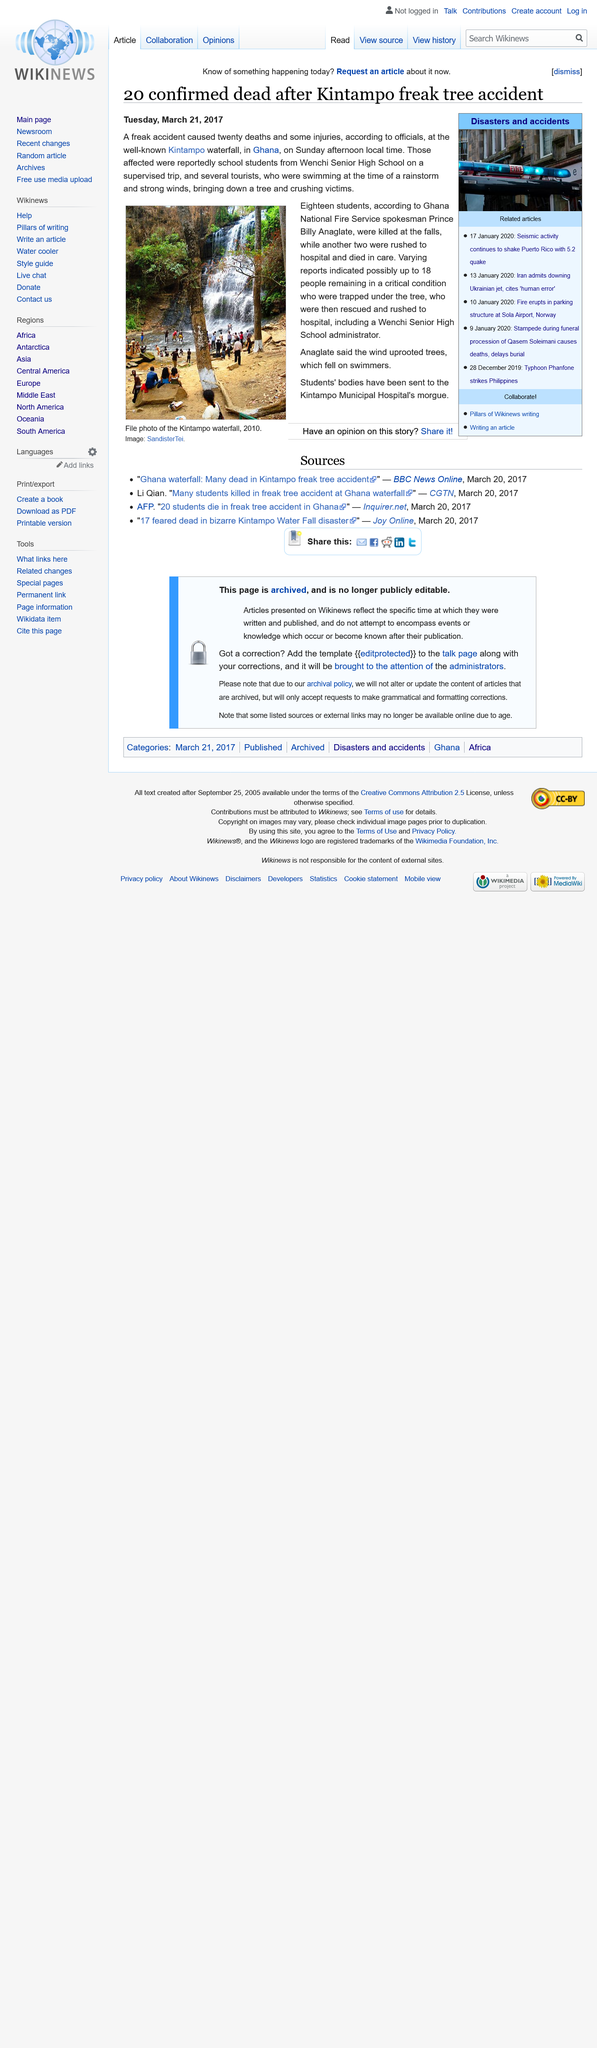Point out several critical features in this image. The wind was responsible for uprooting a tree and crushing people at the Kintampo waterfall in the accident that occurred. The Kintampo Municipal Hospital's morgue has received the bodies of the students. Twenty people died in the accident, according to officials. 